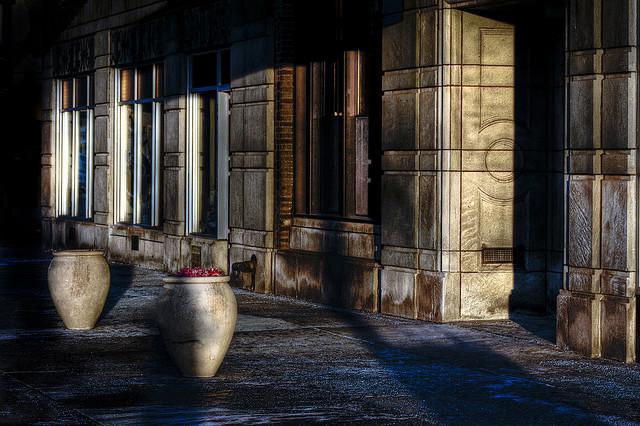What is the building made of?
Write a very short answer. Stone. What color flowers are in the vase?
Write a very short answer. Red. Are the vases on a table?
Short answer required. No. 